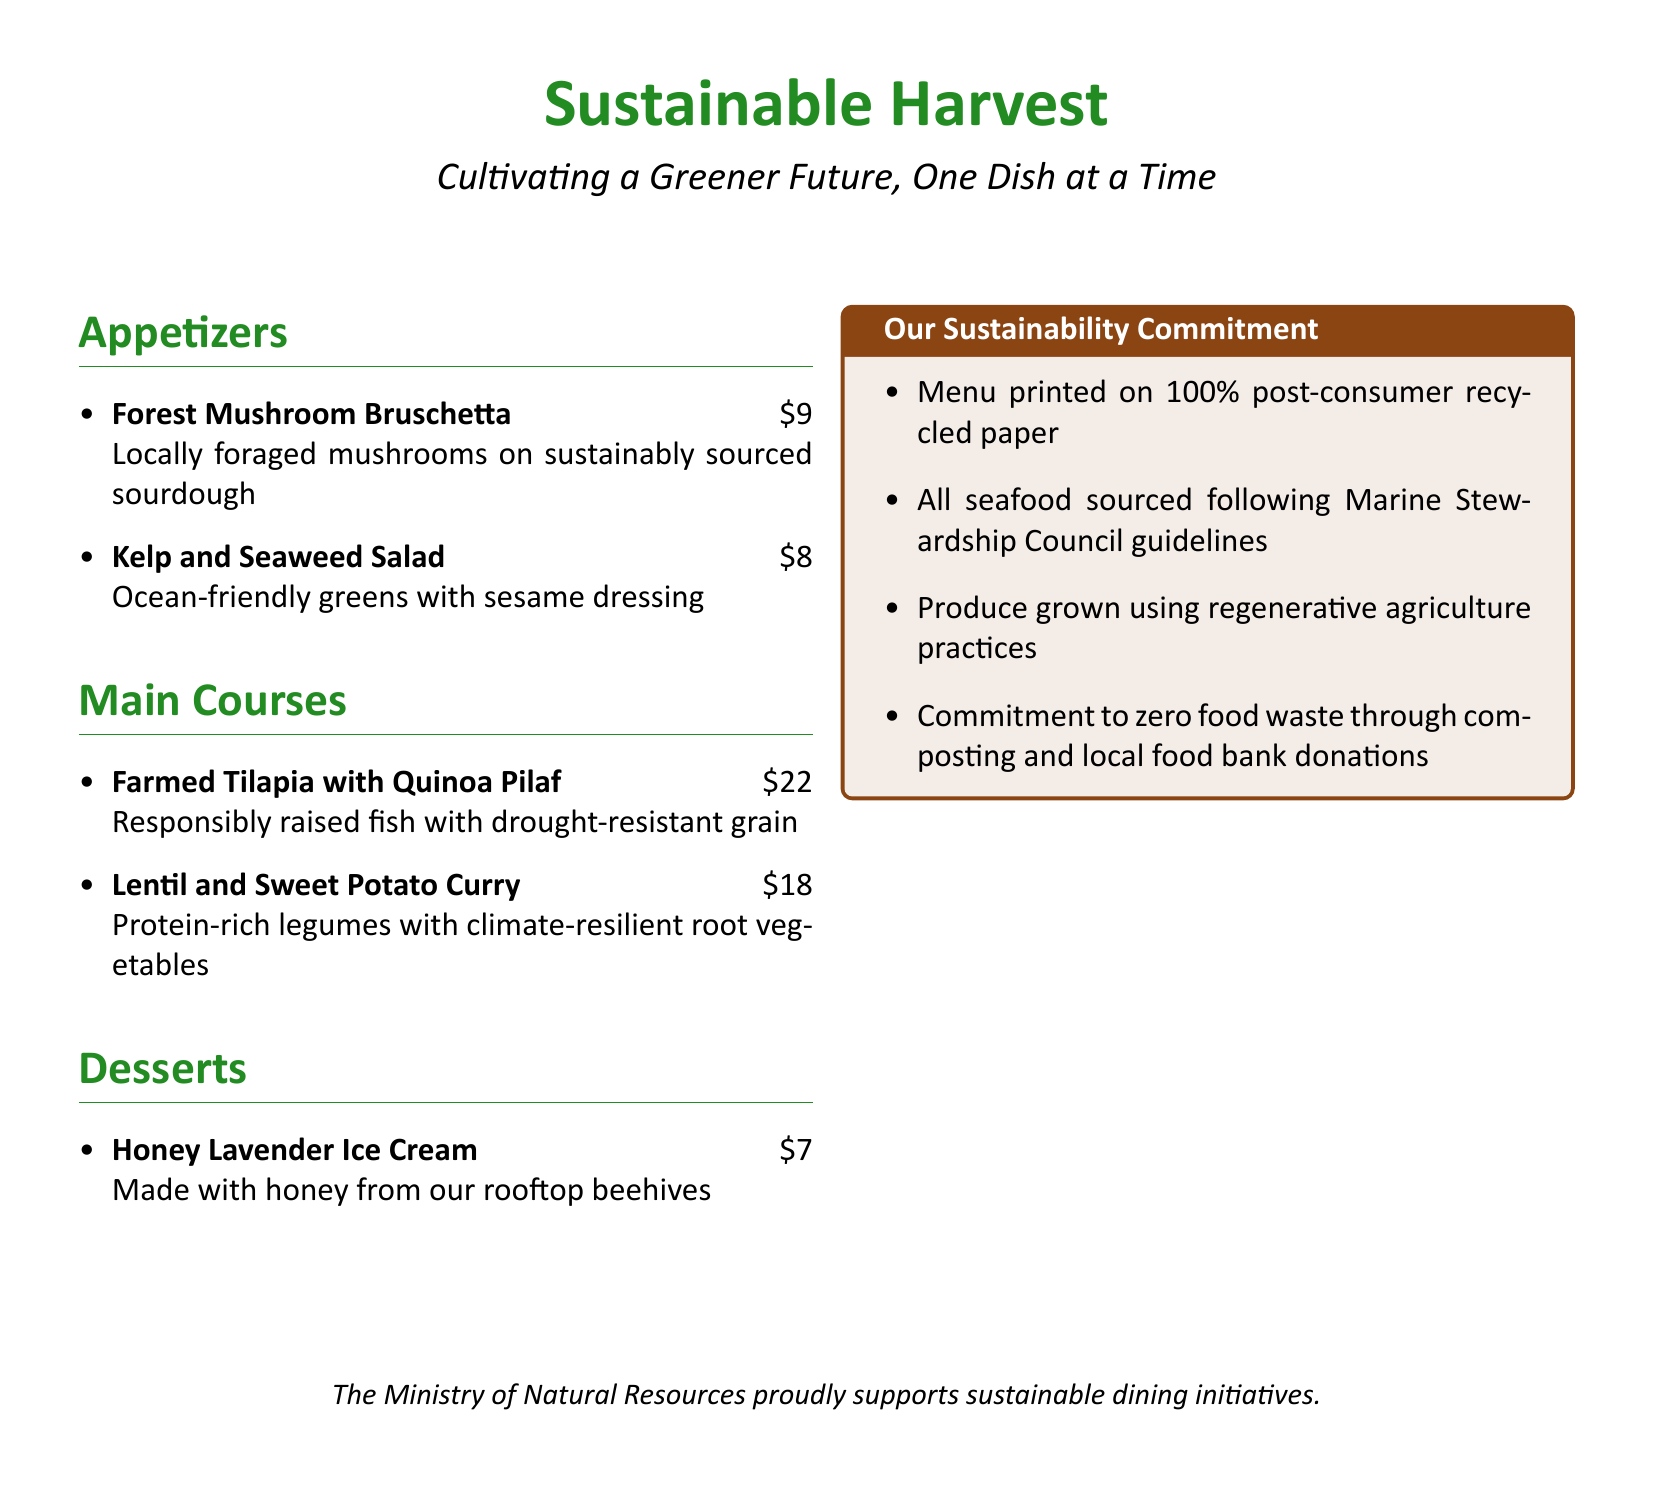what is the price of the Forest Mushroom Bruschetta? The price is listed next to the dish in the appetizers section of the menu.
Answer: $9 what type of dressing is used in the Kelp and Seaweed Salad? The dressing is mentioned in the description of the salad in the appetizers section.
Answer: sesame dressing what is the main ingredient in the Lentil and Sweet Potato Curry? The main ingredient is noted in the description of the dish in the main courses section.
Answer: legumes how much does the Honey Lavender Ice Cream cost? The cost is provided next to the dessert in the menu.
Answer: $7 which sustainable practice is mentioned for sourcing seafood? The document states guidelines under which the seafood is sourced in the sustainability commitment section.
Answer: Marine Stewardship Council guidelines what type of paper is the menu printed on? The paper type is outlined in the sustainability commitment section of the document.
Answer: 100% post-consumer recycled paper how many dishes are listed in the Main Courses section? This can be determined by counting the number of items listed in that section of the document.
Answer: 2 what is the theme of the restaurant's mission statement? The restaurant's mission statement is presented prominently at the top of the menu.
Answer: Cultivating a Greener Future what local resource is used to make the Honey Lavender Ice Cream? The document specifies the source of honey used in the ice cream dessert description.
Answer: rooftop beehives 